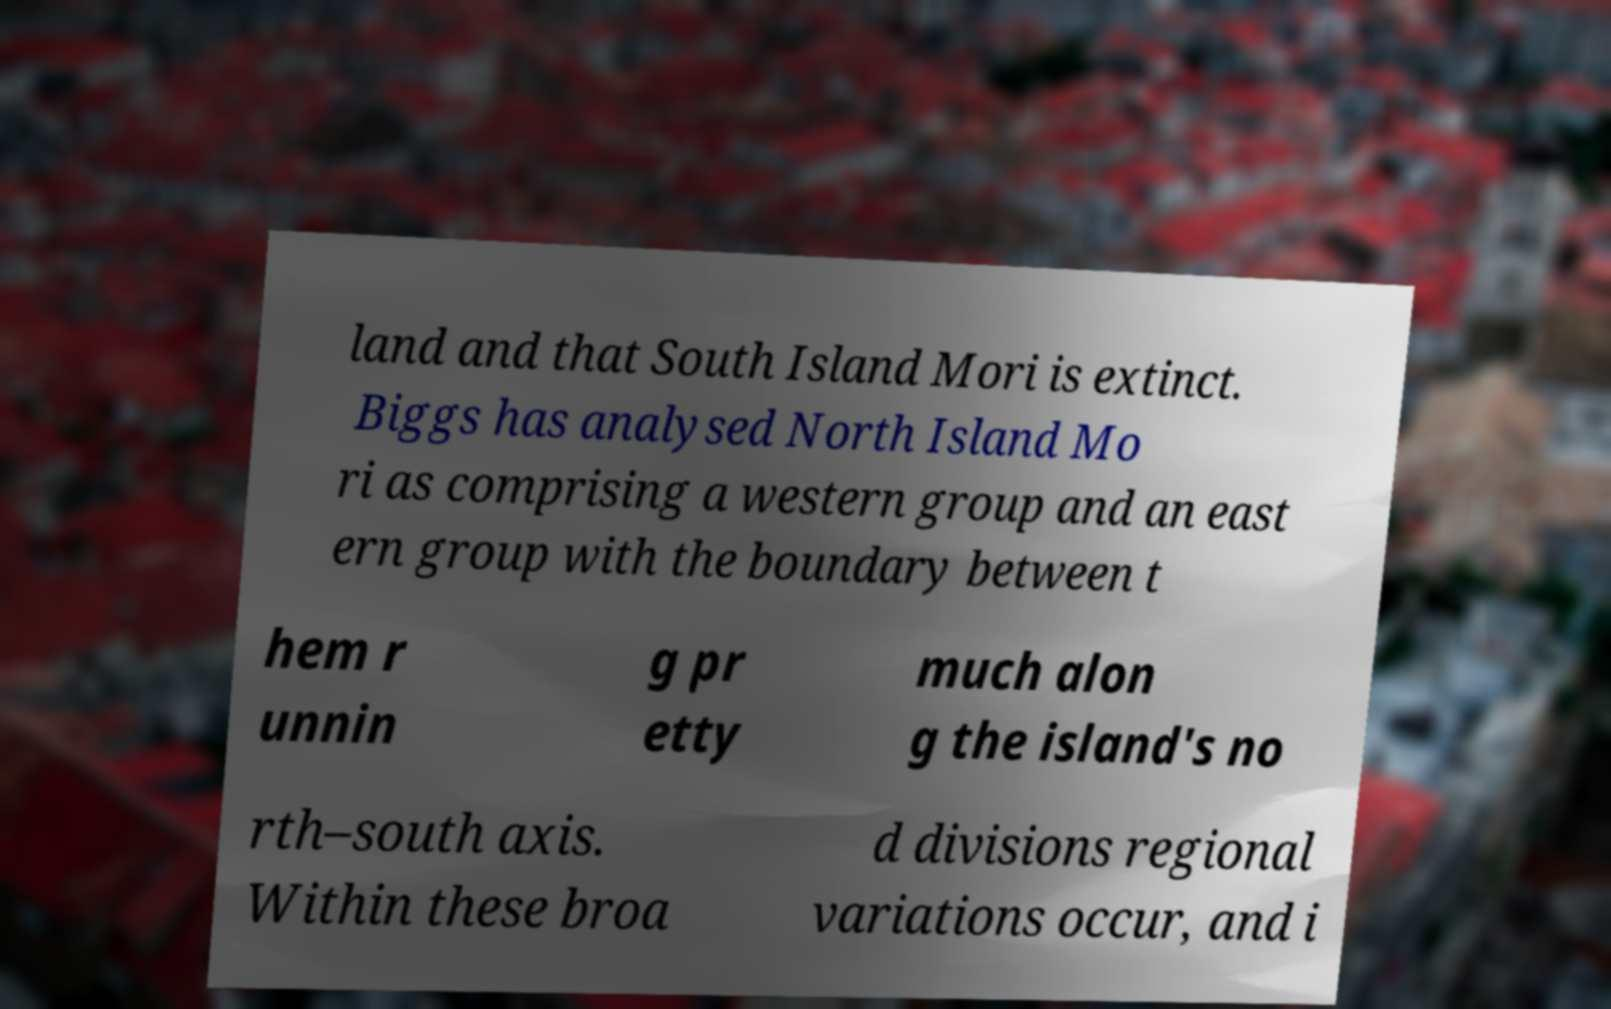Please read and relay the text visible in this image. What does it say? land and that South Island Mori is extinct. Biggs has analysed North Island Mo ri as comprising a western group and an east ern group with the boundary between t hem r unnin g pr etty much alon g the island's no rth–south axis. Within these broa d divisions regional variations occur, and i 